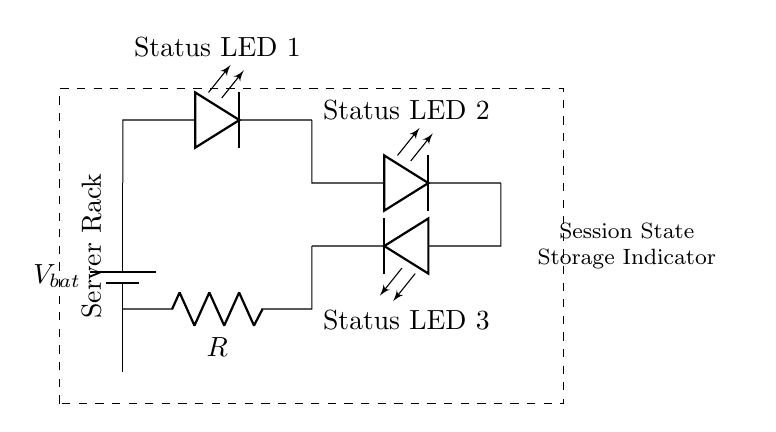What type of circuit is shown in the diagram? The circuit is a series circuit, as all components are connected end-to-end, forming a single path for current.
Answer: Series How many LEDs are in the circuit? There are three LEDs shown in the circuit diagram, labeled as Status LED 1, Status LED 2, and Status LED 3.
Answer: Three What is the purpose of the resistor in this circuit? The resistor is used to limit the current flowing through the LEDs to prevent them from burning out.
Answer: Limit current What does the dashed box represent in the circuit? The dashed box outlines the server rack, indicating that the circuit is used as a part of the server rack setup.
Answer: Server rack What would happen if one LED fails in this series circuit? If one LED fails, it would open the circuit and all LEDs would turn off, as current cannot flow past the failed component in a series arrangement.
Answer: All off What kind of indicator does this circuit represent? The circuit represents a status indicator for session state storage, showing the operational status of the server rack components.
Answer: Session state storage indicator 